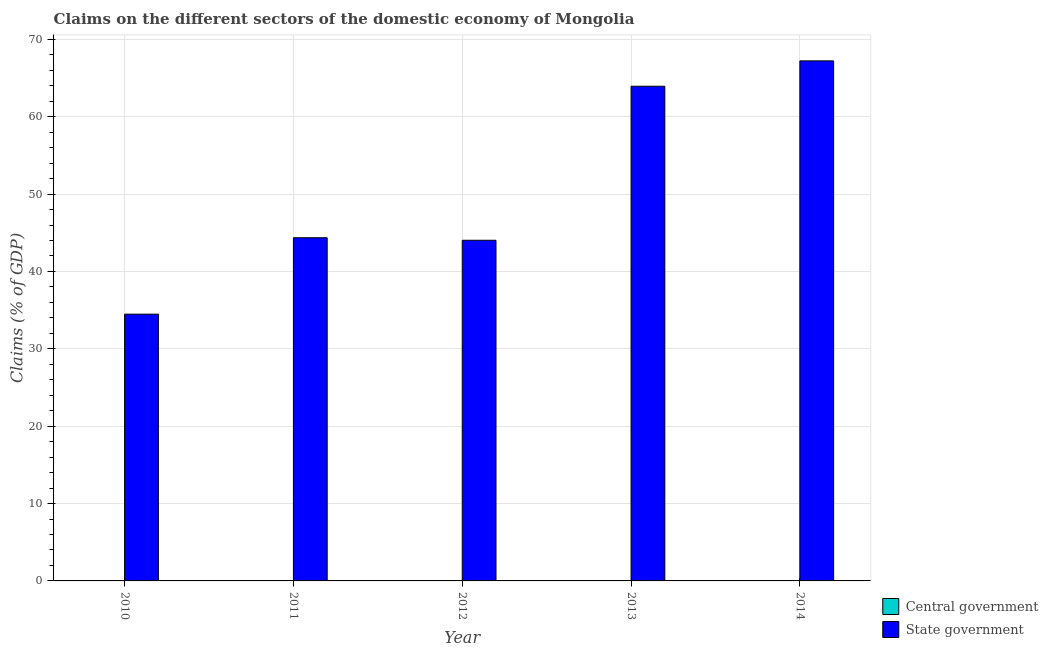How many different coloured bars are there?
Your response must be concise. 1. Are the number of bars on each tick of the X-axis equal?
Your answer should be very brief. Yes. How many bars are there on the 4th tick from the right?
Provide a short and direct response. 1. What is the claims on state government in 2010?
Provide a succinct answer. 34.48. Across all years, what is the maximum claims on state government?
Give a very brief answer. 67.22. Across all years, what is the minimum claims on central government?
Your answer should be compact. 0. What is the total claims on state government in the graph?
Keep it short and to the point. 254.01. What is the difference between the claims on state government in 2010 and that in 2013?
Provide a short and direct response. -29.46. What is the difference between the claims on central government in 2012 and the claims on state government in 2013?
Give a very brief answer. 0. In the year 2011, what is the difference between the claims on state government and claims on central government?
Make the answer very short. 0. What is the ratio of the claims on state government in 2010 to that in 2012?
Provide a short and direct response. 0.78. What is the difference between the highest and the lowest claims on state government?
Provide a succinct answer. 32.74. In how many years, is the claims on central government greater than the average claims on central government taken over all years?
Give a very brief answer. 0. How many bars are there?
Provide a succinct answer. 5. How many years are there in the graph?
Give a very brief answer. 5. What is the difference between two consecutive major ticks on the Y-axis?
Keep it short and to the point. 10. Are the values on the major ticks of Y-axis written in scientific E-notation?
Provide a succinct answer. No. Where does the legend appear in the graph?
Make the answer very short. Bottom right. What is the title of the graph?
Offer a very short reply. Claims on the different sectors of the domestic economy of Mongolia. What is the label or title of the X-axis?
Provide a short and direct response. Year. What is the label or title of the Y-axis?
Your answer should be very brief. Claims (% of GDP). What is the Claims (% of GDP) of State government in 2010?
Give a very brief answer. 34.48. What is the Claims (% of GDP) of Central government in 2011?
Offer a terse response. 0. What is the Claims (% of GDP) in State government in 2011?
Make the answer very short. 44.36. What is the Claims (% of GDP) of State government in 2012?
Make the answer very short. 44.03. What is the Claims (% of GDP) of State government in 2013?
Your response must be concise. 63.94. What is the Claims (% of GDP) in Central government in 2014?
Keep it short and to the point. 0. What is the Claims (% of GDP) in State government in 2014?
Ensure brevity in your answer.  67.22. Across all years, what is the maximum Claims (% of GDP) in State government?
Keep it short and to the point. 67.22. Across all years, what is the minimum Claims (% of GDP) in State government?
Provide a succinct answer. 34.48. What is the total Claims (% of GDP) of State government in the graph?
Keep it short and to the point. 254.01. What is the difference between the Claims (% of GDP) of State government in 2010 and that in 2011?
Offer a very short reply. -9.88. What is the difference between the Claims (% of GDP) in State government in 2010 and that in 2012?
Offer a terse response. -9.55. What is the difference between the Claims (% of GDP) of State government in 2010 and that in 2013?
Your answer should be compact. -29.46. What is the difference between the Claims (% of GDP) in State government in 2010 and that in 2014?
Your answer should be very brief. -32.74. What is the difference between the Claims (% of GDP) of State government in 2011 and that in 2012?
Provide a short and direct response. 0.33. What is the difference between the Claims (% of GDP) in State government in 2011 and that in 2013?
Your response must be concise. -19.58. What is the difference between the Claims (% of GDP) of State government in 2011 and that in 2014?
Your answer should be very brief. -22.86. What is the difference between the Claims (% of GDP) of State government in 2012 and that in 2013?
Make the answer very short. -19.91. What is the difference between the Claims (% of GDP) in State government in 2012 and that in 2014?
Provide a short and direct response. -23.19. What is the difference between the Claims (% of GDP) in State government in 2013 and that in 2014?
Provide a short and direct response. -3.28. What is the average Claims (% of GDP) of Central government per year?
Keep it short and to the point. 0. What is the average Claims (% of GDP) in State government per year?
Keep it short and to the point. 50.8. What is the ratio of the Claims (% of GDP) in State government in 2010 to that in 2011?
Offer a very short reply. 0.78. What is the ratio of the Claims (% of GDP) of State government in 2010 to that in 2012?
Keep it short and to the point. 0.78. What is the ratio of the Claims (% of GDP) in State government in 2010 to that in 2013?
Make the answer very short. 0.54. What is the ratio of the Claims (% of GDP) of State government in 2010 to that in 2014?
Offer a terse response. 0.51. What is the ratio of the Claims (% of GDP) in State government in 2011 to that in 2012?
Offer a terse response. 1.01. What is the ratio of the Claims (% of GDP) of State government in 2011 to that in 2013?
Offer a very short reply. 0.69. What is the ratio of the Claims (% of GDP) of State government in 2011 to that in 2014?
Your answer should be very brief. 0.66. What is the ratio of the Claims (% of GDP) of State government in 2012 to that in 2013?
Make the answer very short. 0.69. What is the ratio of the Claims (% of GDP) in State government in 2012 to that in 2014?
Offer a very short reply. 0.66. What is the ratio of the Claims (% of GDP) of State government in 2013 to that in 2014?
Your answer should be very brief. 0.95. What is the difference between the highest and the second highest Claims (% of GDP) in State government?
Your response must be concise. 3.28. What is the difference between the highest and the lowest Claims (% of GDP) of State government?
Offer a very short reply. 32.74. 